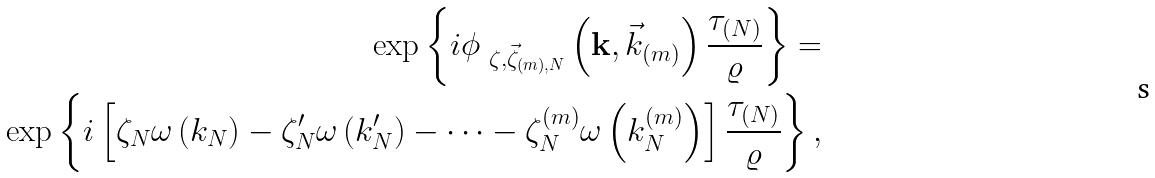<formula> <loc_0><loc_0><loc_500><loc_500>\exp \left \{ i \phi _ { \ \zeta , \vec { \zeta } _ { \left ( m \right ) , N } } \left ( \mathbf { k } , \vec { k } _ { \left ( m \right ) } \right ) \frac { \tau _ { \left ( N \right ) } } { \varrho } \right \} = \\ \exp \left \{ i \left [ \zeta _ { N } \omega \left ( k _ { N } \right ) - \zeta _ { N } ^ { \prime } \omega \left ( k _ { N } ^ { \prime } \right ) - \dots - \zeta _ { N } ^ { \left ( m \right ) } \omega \left ( k _ { N } ^ { \left ( m \right ) } \right ) \right ] \frac { \tau _ { \left ( N \right ) } } { \varrho } \right \} ,</formula> 